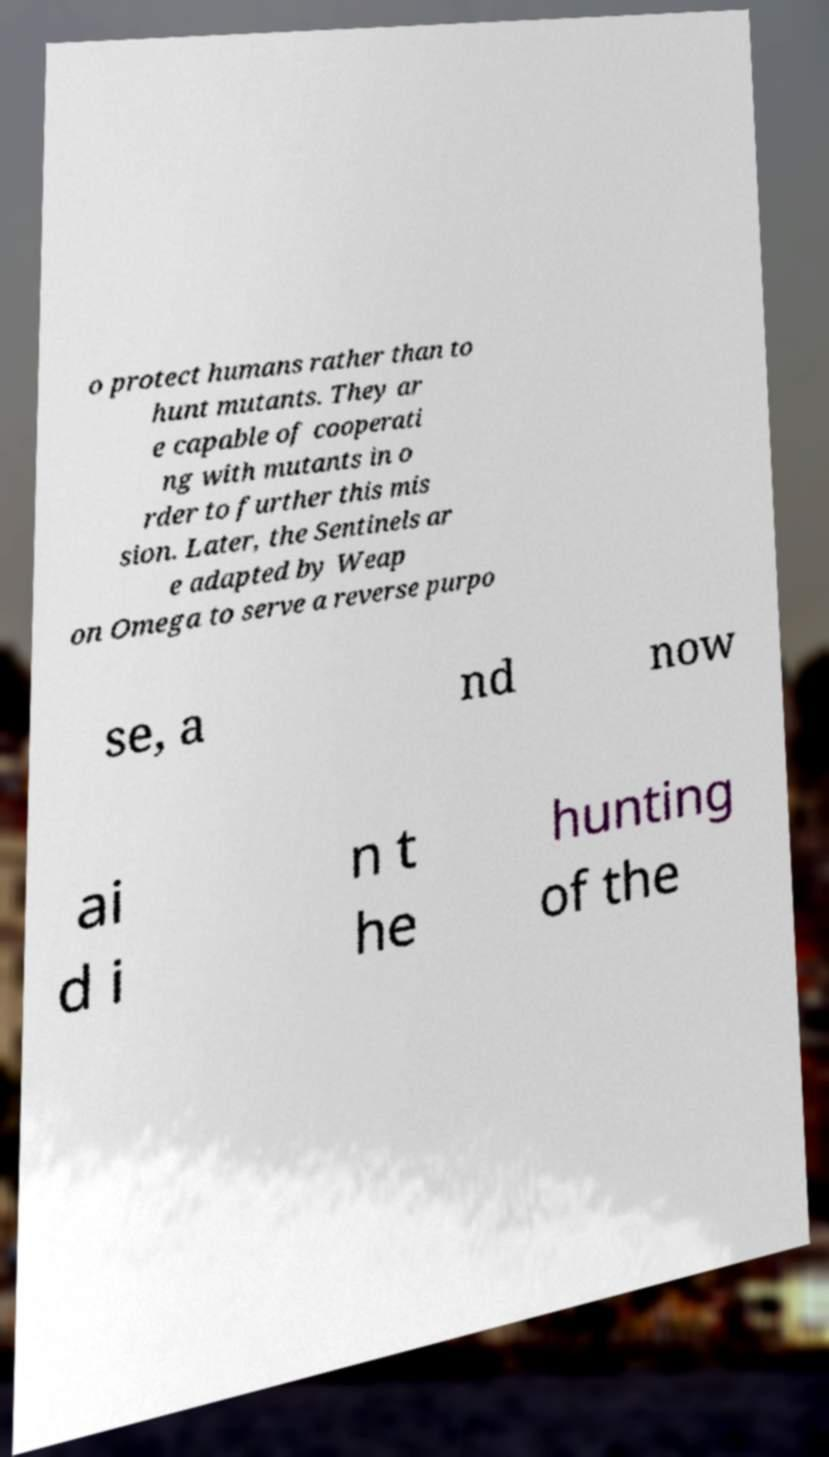There's text embedded in this image that I need extracted. Can you transcribe it verbatim? o protect humans rather than to hunt mutants. They ar e capable of cooperati ng with mutants in o rder to further this mis sion. Later, the Sentinels ar e adapted by Weap on Omega to serve a reverse purpo se, a nd now ai d i n t he hunting of the 